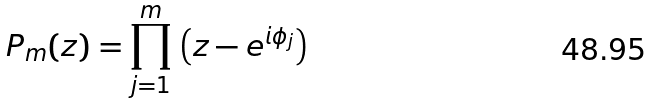Convert formula to latex. <formula><loc_0><loc_0><loc_500><loc_500>P _ { m } ( z ) = \prod _ { j = 1 } ^ { m } \, \left ( z - e ^ { i \phi _ { j } } \right )</formula> 